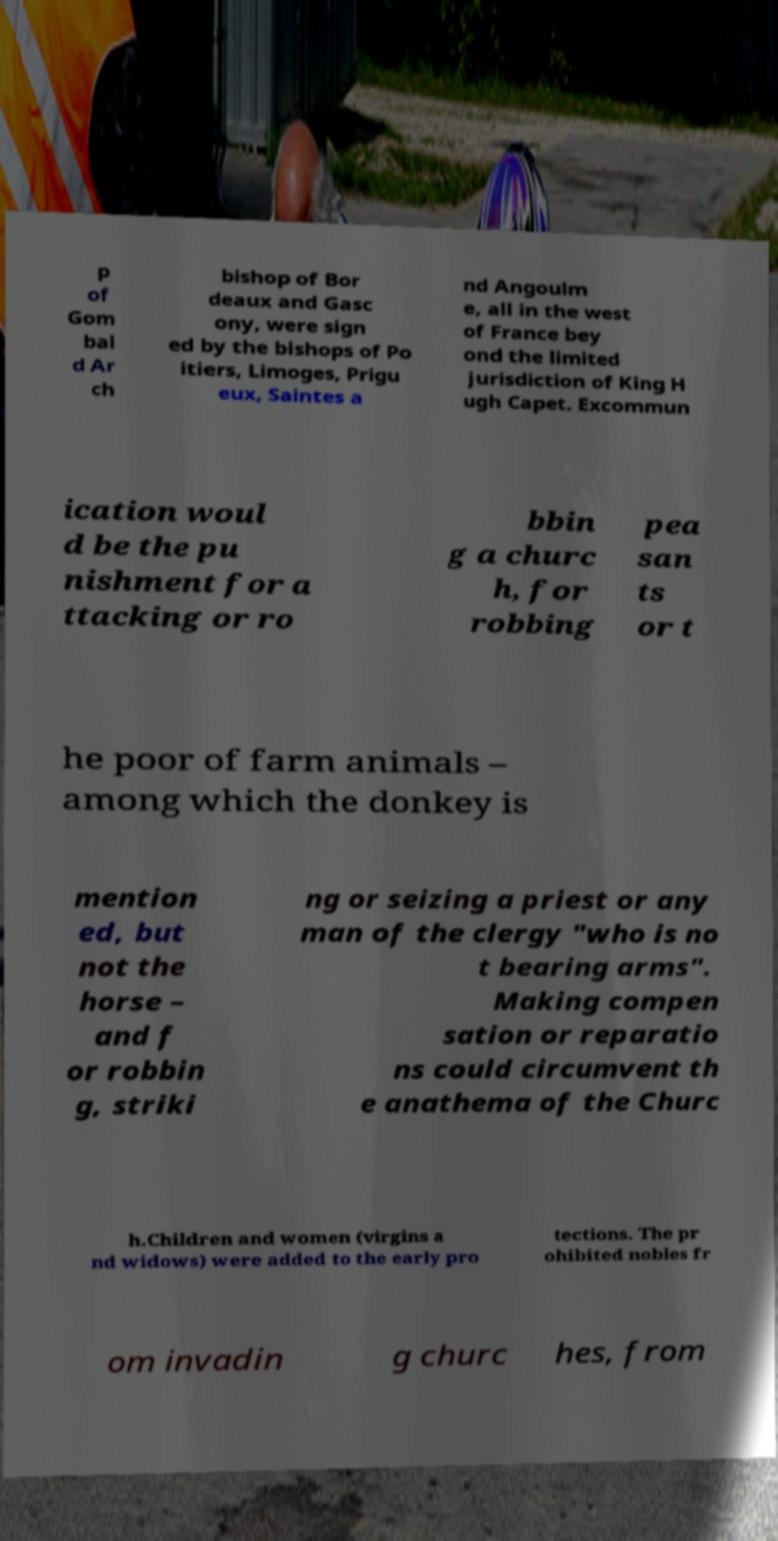Could you extract and type out the text from this image? p of Gom bal d Ar ch bishop of Bor deaux and Gasc ony, were sign ed by the bishops of Po itiers, Limoges, Prigu eux, Saintes a nd Angoulm e, all in the west of France bey ond the limited jurisdiction of King H ugh Capet. Excommun ication woul d be the pu nishment for a ttacking or ro bbin g a churc h, for robbing pea san ts or t he poor of farm animals – among which the donkey is mention ed, but not the horse – and f or robbin g, striki ng or seizing a priest or any man of the clergy "who is no t bearing arms". Making compen sation or reparatio ns could circumvent th e anathema of the Churc h.Children and women (virgins a nd widows) were added to the early pro tections. The pr ohibited nobles fr om invadin g churc hes, from 